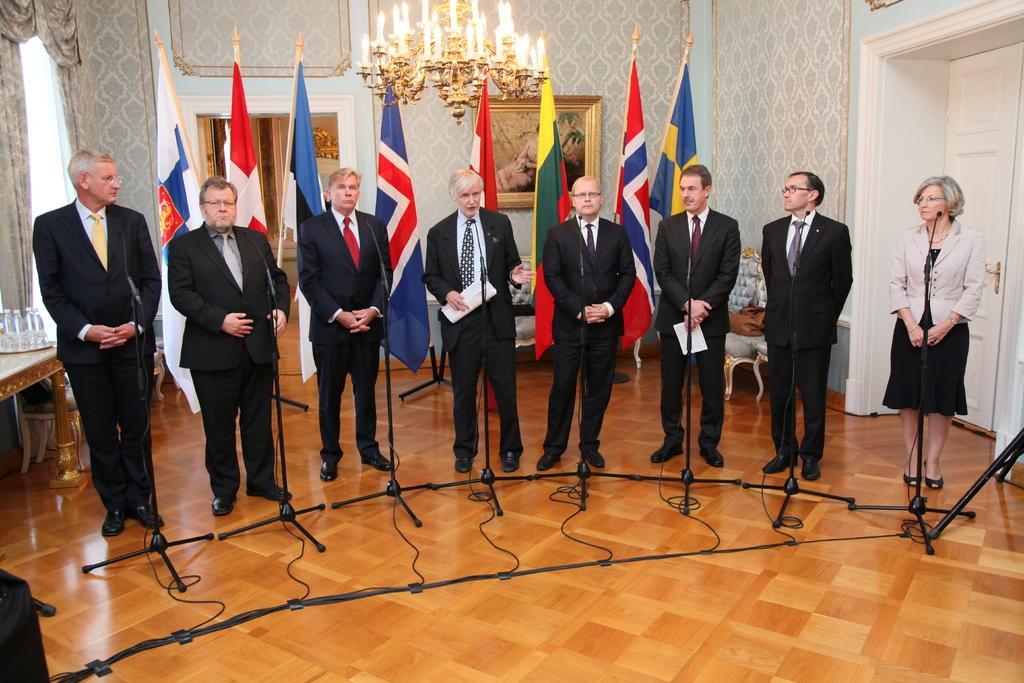Please provide a concise description of this image. In the image we can see there are seven men and a woman standing, wearing clothes, shoes and some of them are wearing spectacles. Here we can see there are microphones, cable wires and wooden floor. We can even see there are flags of the countries and we can see the table. On the table there are bottles. Here we can see the curtains and the frame stick to the wall. Here we can see chandelier 